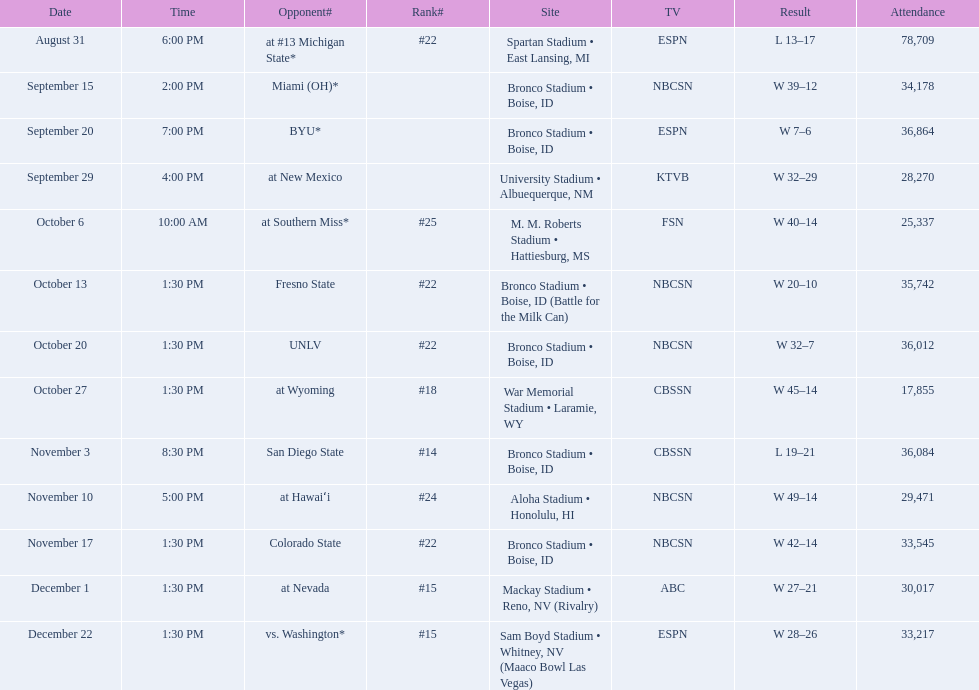What are all of the rankings? #22, , , , #25, #22, #22, #18, #14, #24, #22, #15, #15. Which of them was the best position? #14. 